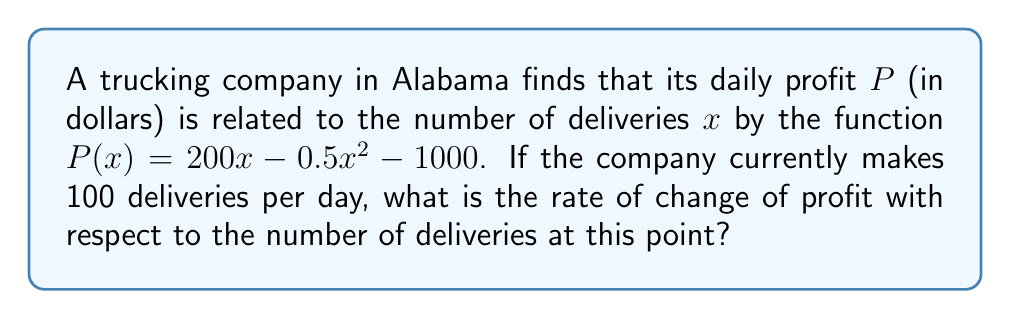Help me with this question. To find the rate of change of profit with respect to the number of deliveries, we need to calculate the derivative of the profit function $P(x)$ and evaluate it at $x = 100$.

1. Given profit function: $P(x) = 200x - 0.5x^2 - 1000$

2. Calculate the derivative $P'(x)$:
   $$\begin{align}
   P'(x) &= \frac{d}{dx}(200x - 0.5x^2 - 1000) \\
   &= 200 - x
   \end{align}$$

3. Evaluate $P'(x)$ at $x = 100$:
   $$\begin{align}
   P'(100) &= 200 - 100 \\
   &= 100
   \end{align}$$

The rate of change of profit with respect to the number of deliveries when the company makes 100 deliveries per day is 100 dollars per delivery.
Answer: $100 per delivery 